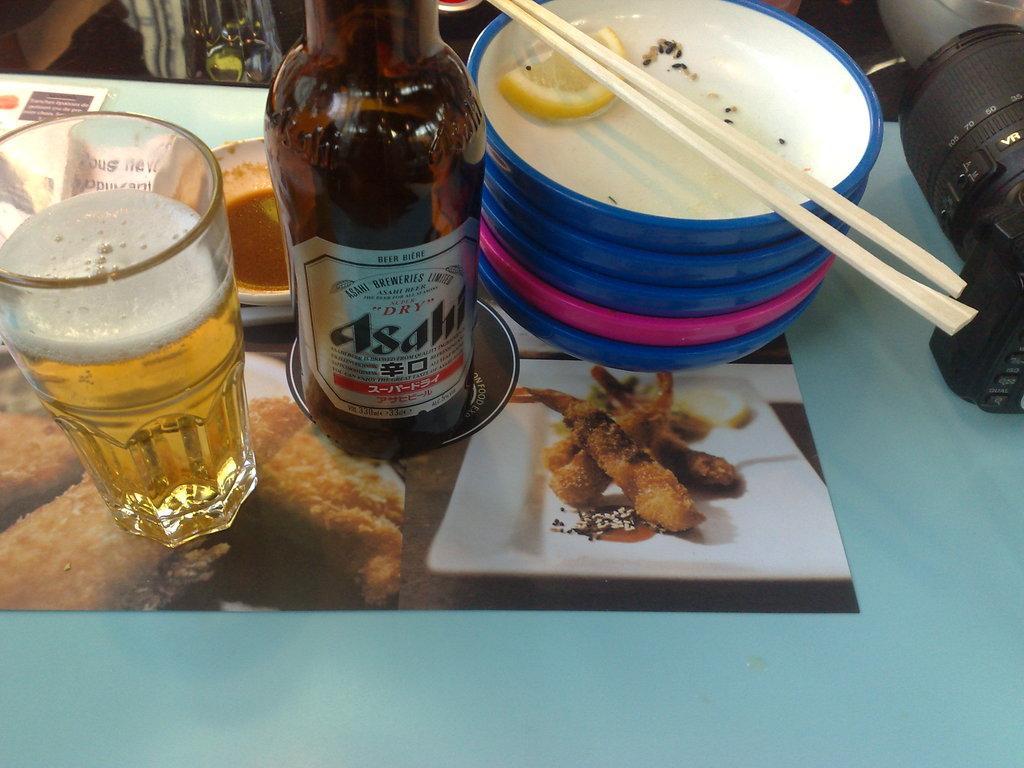Can you describe this image briefly? There are wine bottle,a glass filled with wine,some plates,a pair of chopsticks and a camera on a table. 